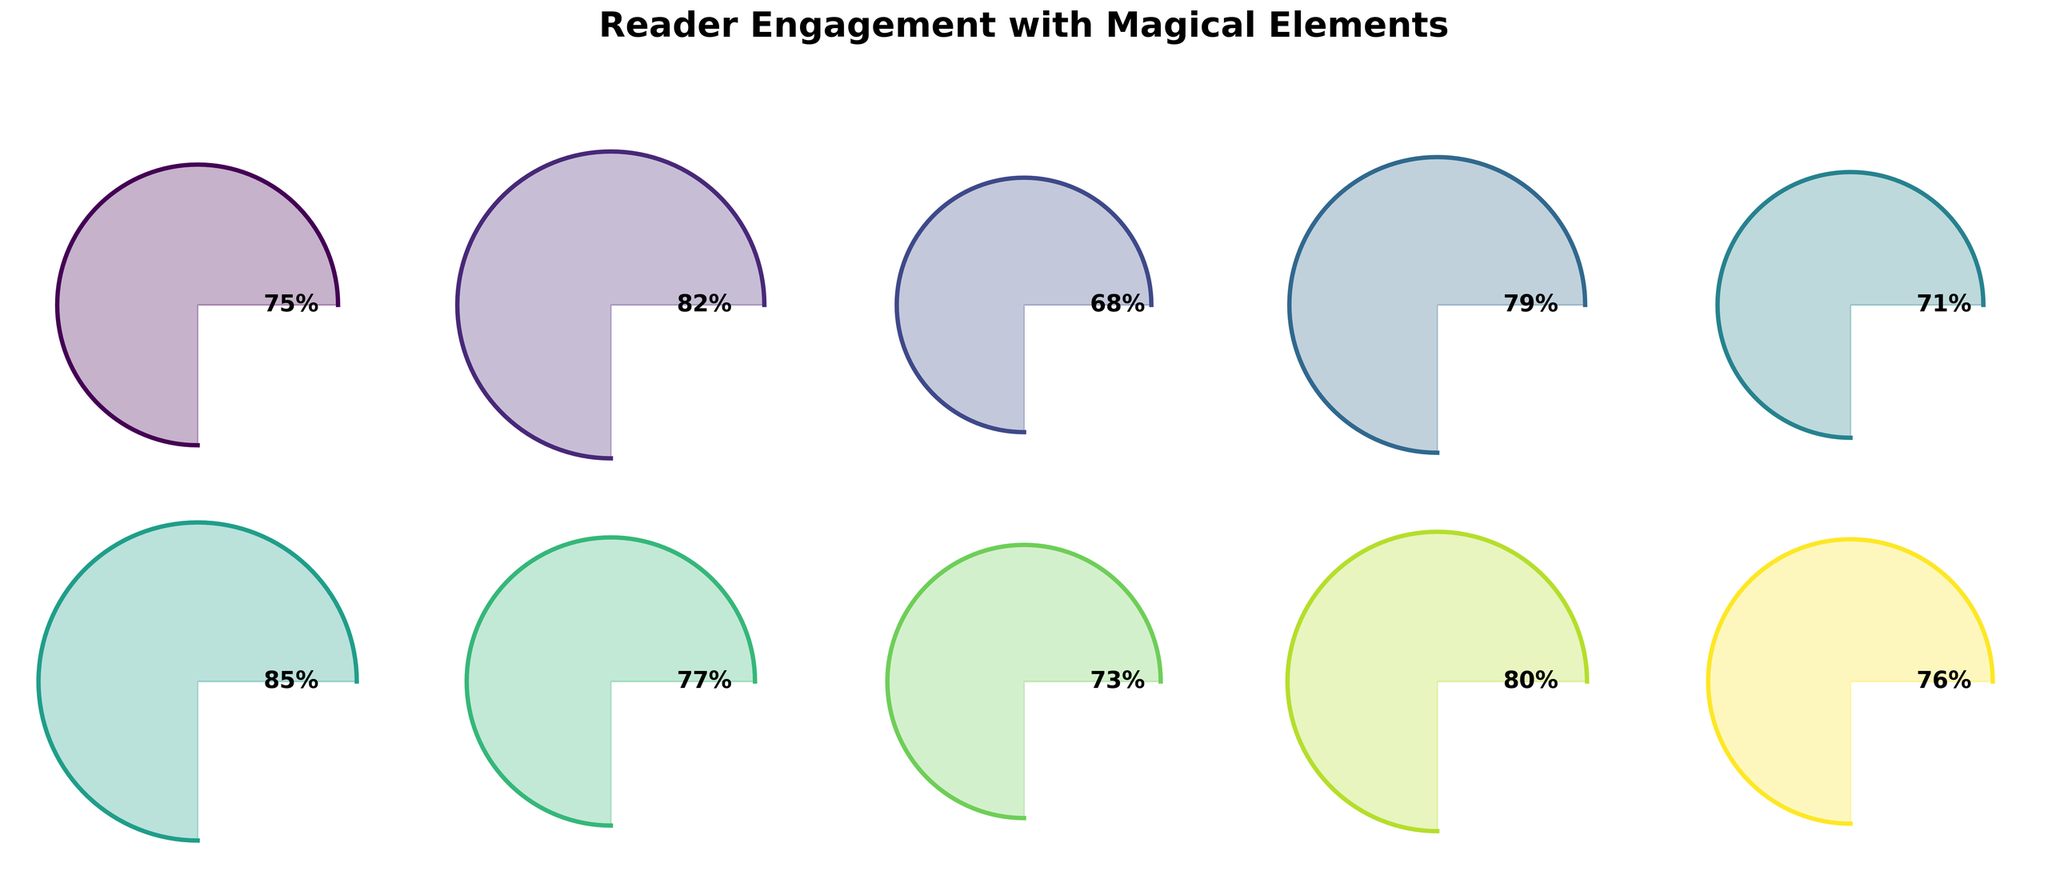What's the title of the figure? The title is clearly written at the top of the figure.
Answer: Reader Engagement with Magical Elements Which magical element has the highest reader engagement? The figure shows different values for each magical element. The highest value corresponds to Time Manipulation.
Answer: Time Manipulation Which magical element has the lowest reading engagement? By looking at all the values, the lowest one is for Spellcasting Systems.
Answer: Spellcasting Systems What is the average reader engagement across all magical elements? First, sum all values: (75 + 82 + 68 + 79 + 71 + 85 + 77 + 73 + 80 + 76) = 766. Then, divide by the number of elements: 766 / 10.
Answer: 76.6 How does reader engagement with Unique Magical Creatures compare to that with Enchanted Locations? The value for Unique Magical Creatures is 82 and for Enchanted Locations is 71. Unique Magical Creatures is higher.
Answer: Unique Magical Creatures is higher Are there any magical elements with exactly the same engagement level? By examining all values, there are no two elements with the same engagement level.
Answer: No What is the total reader engagement for Elemental Magic and Magical Transformations combined? Sum the values of both Elemental Magic and Magical Transformations: 75 + 77.
Answer: 152 Which category has an engagement level closest to 80%? The value closest to 80% is for Otherworldly Dimensions, which has exactly 80%.
Answer: Otherworldly Dimensions How many magical elements have an engagement level above 70%? Count the elements with values greater than 70%: Elemental Magic, Unique Magical Creatures, Magical Artifacts, Time Manipulation, Magical Transformations, Mystical Prophecies, Otherworldly Dimensions, and Ancient Rituals.
Answer: 8 What is the difference in engagement level between Mystical Prophecies and Unique Magical Creatures? Subtract the value of Mystical Prophecies from that of Unique Magical Creatures: 82 - 73.
Answer: 9 